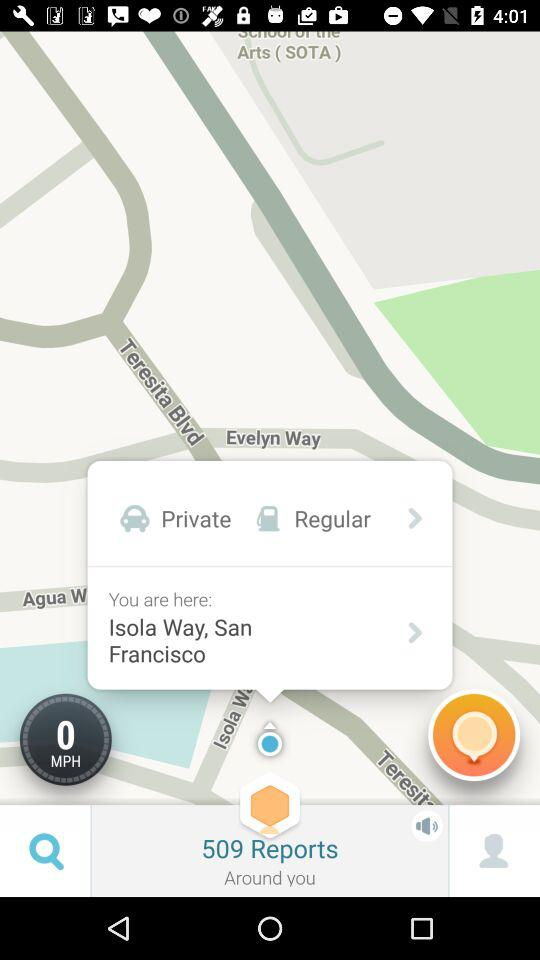What is the location? The location is Isola Way, San Francisco. 